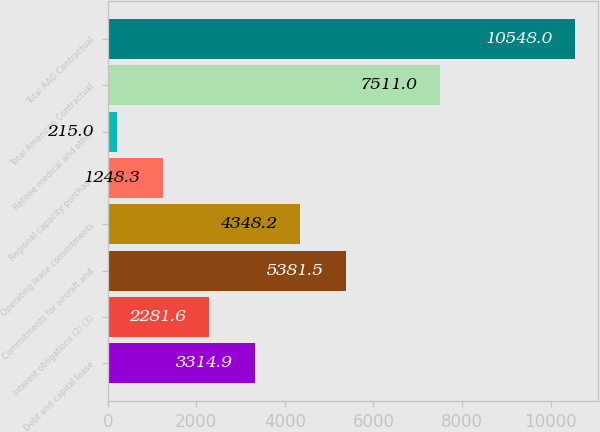<chart> <loc_0><loc_0><loc_500><loc_500><bar_chart><fcel>Debt and capital lease<fcel>Interest obligations (2) (3)<fcel>Commitments for aircraft and<fcel>Operating lease commitments<fcel>Regional capacity purchase<fcel>Retiree medical and other<fcel>Total American Contractual<fcel>Total AAG Contractual<nl><fcel>3314.9<fcel>2281.6<fcel>5381.5<fcel>4348.2<fcel>1248.3<fcel>215<fcel>7511<fcel>10548<nl></chart> 